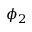Convert formula to latex. <formula><loc_0><loc_0><loc_500><loc_500>\phi _ { 2 }</formula> 